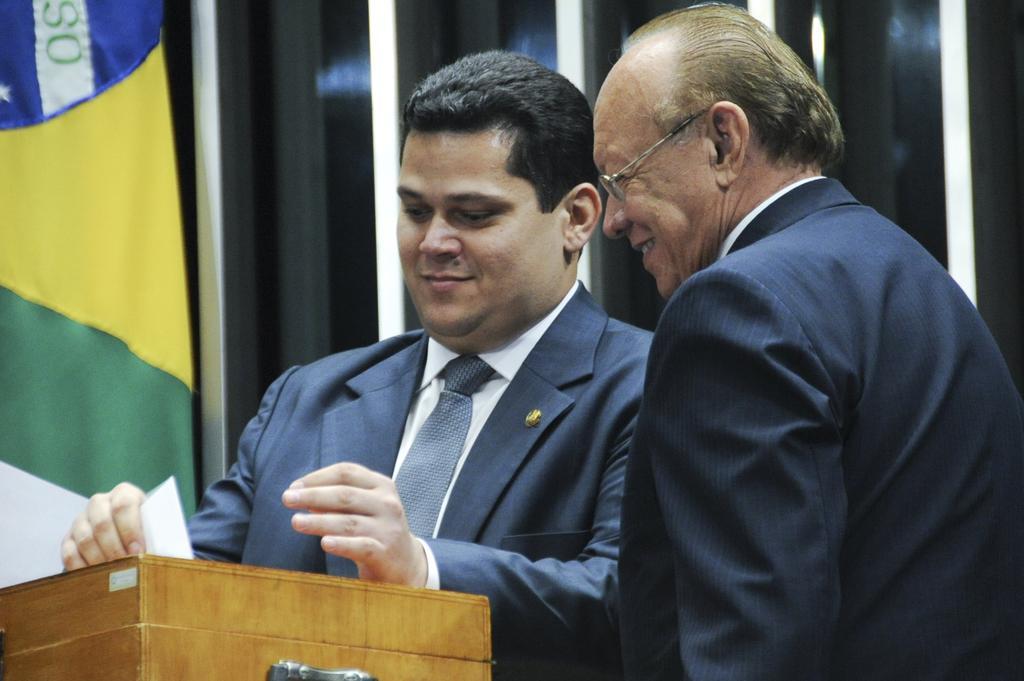How would you summarize this image in a sentence or two? In the image in the center, we can see two persons are standing and they are smiling. In front of them,there is a wooden stand. In the background there is a wall and a curtain. 